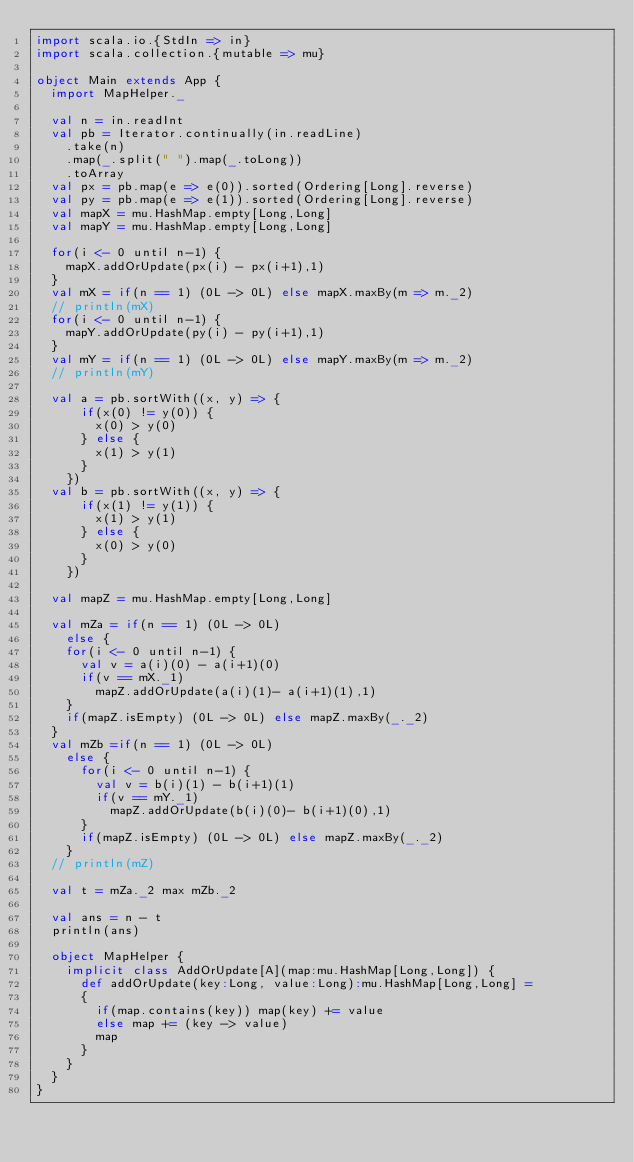Convert code to text. <code><loc_0><loc_0><loc_500><loc_500><_Scala_>import scala.io.{StdIn => in}
import scala.collection.{mutable => mu}

object Main extends App {
  import MapHelper._

  val n = in.readInt
  val pb = Iterator.continually(in.readLine)
    .take(n)
    .map(_.split(" ").map(_.toLong))
    .toArray
  val px = pb.map(e => e(0)).sorted(Ordering[Long].reverse)
  val py = pb.map(e => e(1)).sorted(Ordering[Long].reverse)
  val mapX = mu.HashMap.empty[Long,Long]
  val mapY = mu.HashMap.empty[Long,Long]

  for(i <- 0 until n-1) {
    mapX.addOrUpdate(px(i) - px(i+1),1)
  }
  val mX = if(n == 1) (0L -> 0L) else mapX.maxBy(m => m._2)
  // println(mX)
  for(i <- 0 until n-1) {
    mapY.addOrUpdate(py(i) - py(i+1),1)
  }
  val mY = if(n == 1) (0L -> 0L) else mapY.maxBy(m => m._2)
  // println(mY)

  val a = pb.sortWith((x, y) => {
      if(x(0) != y(0)) {
        x(0) > y(0)
      } else {
        x(1) > y(1)
      }
    })
  val b = pb.sortWith((x, y) => {
      if(x(1) != y(1)) {
        x(1) > y(1)
      } else {
        x(0) > y(0)
      }
    })

  val mapZ = mu.HashMap.empty[Long,Long]

  val mZa = if(n == 1) (0L -> 0L)
    else {
    for(i <- 0 until n-1) {
      val v = a(i)(0) - a(i+1)(0)
      if(v == mX._1)
        mapZ.addOrUpdate(a(i)(1)- a(i+1)(1),1)
    }
    if(mapZ.isEmpty) (0L -> 0L) else mapZ.maxBy(_._2)
  }
  val mZb =if(n == 1) (0L -> 0L)
    else {
      for(i <- 0 until n-1) {
        val v = b(i)(1) - b(i+1)(1)
        if(v == mY._1)
          mapZ.addOrUpdate(b(i)(0)- b(i+1)(0),1)
      }
      if(mapZ.isEmpty) (0L -> 0L) else mapZ.maxBy(_._2)
    }
  // println(mZ)

  val t = mZa._2 max mZb._2

  val ans = n - t
  println(ans)

  object MapHelper {
    implicit class AddOrUpdate[A](map:mu.HashMap[Long,Long]) {
      def addOrUpdate(key:Long, value:Long):mu.HashMap[Long,Long] =
      {
        if(map.contains(key)) map(key) += value
        else map += (key -> value)
        map
      }
    }
  }
}</code> 